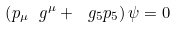<formula> <loc_0><loc_0><loc_500><loc_500>\left ( p _ { \mu } \ g ^ { \mu } + \ g _ { 5 } p _ { 5 } \right ) \psi = 0</formula> 